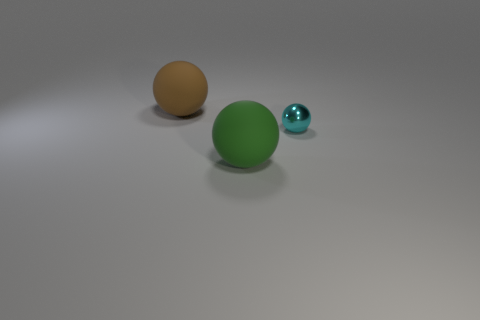Add 3 cyan balls. How many objects exist? 6 Add 2 big spheres. How many big spheres are left? 4 Add 3 brown objects. How many brown objects exist? 4 Subtract 0 purple balls. How many objects are left? 3 Subtract all cyan objects. Subtract all small objects. How many objects are left? 1 